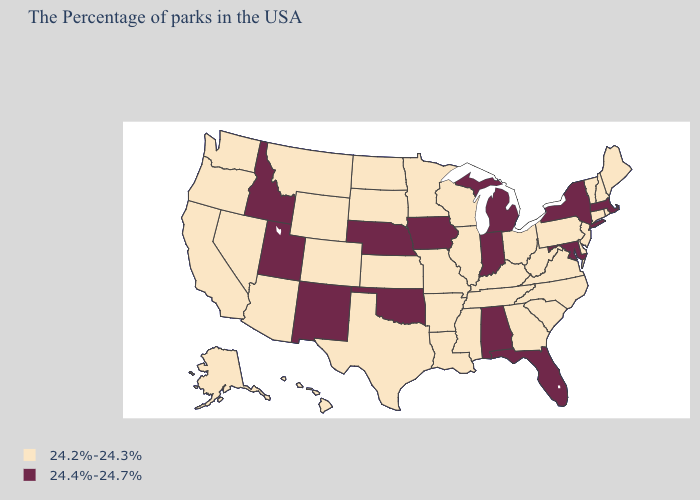Which states have the highest value in the USA?
Answer briefly. Massachusetts, New York, Maryland, Florida, Michigan, Indiana, Alabama, Iowa, Nebraska, Oklahoma, New Mexico, Utah, Idaho. Does Wisconsin have the same value as Indiana?
Short answer required. No. What is the value of Maryland?
Short answer required. 24.4%-24.7%. Among the states that border Texas , does New Mexico have the lowest value?
Be succinct. No. What is the lowest value in the USA?
Answer briefly. 24.2%-24.3%. Does the map have missing data?
Be succinct. No. Does Kentucky have the highest value in the South?
Give a very brief answer. No. Is the legend a continuous bar?
Short answer required. No. Name the states that have a value in the range 24.4%-24.7%?
Short answer required. Massachusetts, New York, Maryland, Florida, Michigan, Indiana, Alabama, Iowa, Nebraska, Oklahoma, New Mexico, Utah, Idaho. Name the states that have a value in the range 24.4%-24.7%?
Concise answer only. Massachusetts, New York, Maryland, Florida, Michigan, Indiana, Alabama, Iowa, Nebraska, Oklahoma, New Mexico, Utah, Idaho. What is the value of Connecticut?
Write a very short answer. 24.2%-24.3%. What is the value of California?
Concise answer only. 24.2%-24.3%. Name the states that have a value in the range 24.2%-24.3%?
Write a very short answer. Maine, Rhode Island, New Hampshire, Vermont, Connecticut, New Jersey, Delaware, Pennsylvania, Virginia, North Carolina, South Carolina, West Virginia, Ohio, Georgia, Kentucky, Tennessee, Wisconsin, Illinois, Mississippi, Louisiana, Missouri, Arkansas, Minnesota, Kansas, Texas, South Dakota, North Dakota, Wyoming, Colorado, Montana, Arizona, Nevada, California, Washington, Oregon, Alaska, Hawaii. Does West Virginia have a higher value than Missouri?
Be succinct. No. 